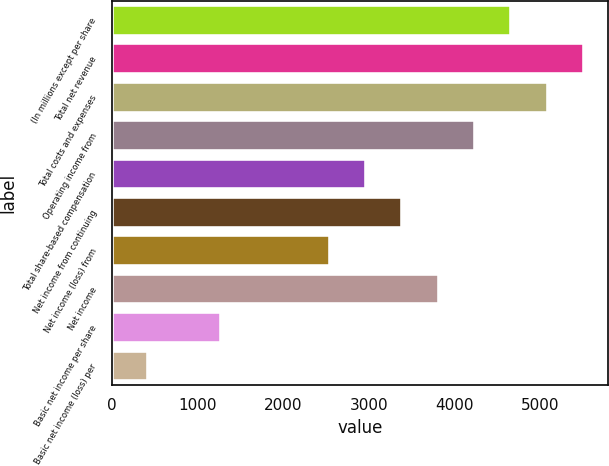Convert chart to OTSL. <chart><loc_0><loc_0><loc_500><loc_500><bar_chart><fcel>(In millions except per share<fcel>Total net revenue<fcel>Total costs and expenses<fcel>Operating income from<fcel>Total share-based compensation<fcel>Net income from continuing<fcel>Net income (loss) from<fcel>Net income<fcel>Basic net income per share<fcel>Basic net income (loss) per<nl><fcel>4667.26<fcel>5515.82<fcel>5091.54<fcel>4242.98<fcel>2970.14<fcel>3394.42<fcel>2545.86<fcel>3818.7<fcel>1273.02<fcel>424.46<nl></chart> 